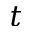<formula> <loc_0><loc_0><loc_500><loc_500>t</formula> 